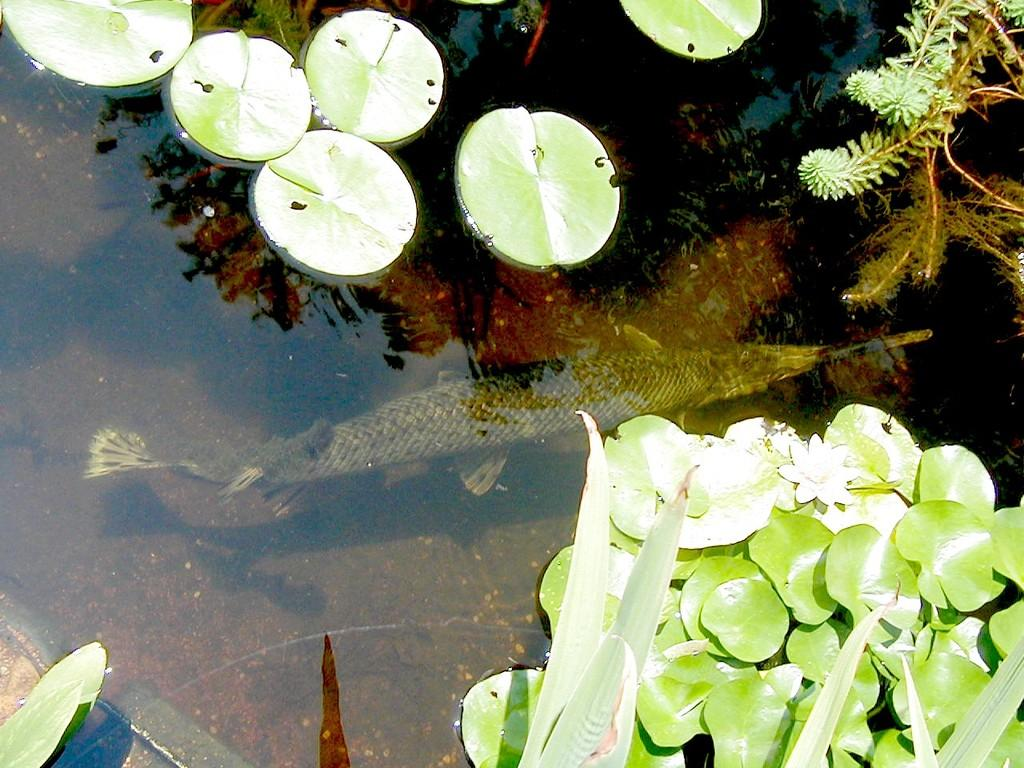What animals can be seen in the water in the image? There are two fish in the water in the image. What is present at the bottom of the image? There are leaves on the bottom of the image. What type of vegetation is visible on the top right of the image? There is grass on the top right of the image. What other natural elements can be seen in the image? There is a tree visible in the image, and the sky is visible in the image through the water reflection. Can you see any grapes hanging from the tree in the image? There are no grapes visible in the image; only leaves and a tree can be seen. Is there an airplane flying in the sky in the image? There is no airplane visible in the image; only the sky is visible through the water reflection. Is there snow on the ground in the image? There is no snow present in the image; the ground is covered with grass and leaves. 